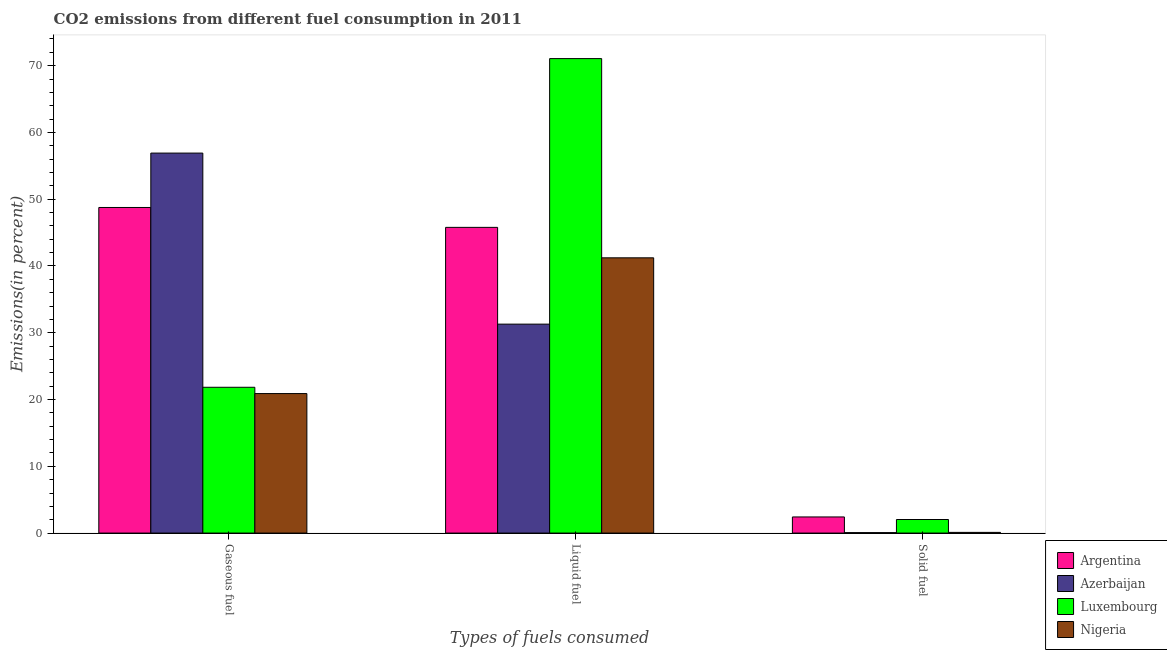How many different coloured bars are there?
Provide a short and direct response. 4. How many groups of bars are there?
Offer a very short reply. 3. How many bars are there on the 1st tick from the left?
Provide a succinct answer. 4. How many bars are there on the 3rd tick from the right?
Provide a short and direct response. 4. What is the label of the 1st group of bars from the left?
Provide a succinct answer. Gaseous fuel. What is the percentage of solid fuel emission in Nigeria?
Your answer should be compact. 0.1. Across all countries, what is the maximum percentage of gaseous fuel emission?
Your response must be concise. 56.9. Across all countries, what is the minimum percentage of liquid fuel emission?
Provide a succinct answer. 31.29. In which country was the percentage of liquid fuel emission maximum?
Your response must be concise. Luxembourg. In which country was the percentage of liquid fuel emission minimum?
Your answer should be compact. Azerbaijan. What is the total percentage of liquid fuel emission in the graph?
Your answer should be compact. 189.35. What is the difference between the percentage of gaseous fuel emission in Argentina and that in Azerbaijan?
Give a very brief answer. -8.14. What is the difference between the percentage of solid fuel emission in Luxembourg and the percentage of liquid fuel emission in Azerbaijan?
Make the answer very short. -29.26. What is the average percentage of liquid fuel emission per country?
Provide a succinct answer. 47.34. What is the difference between the percentage of gaseous fuel emission and percentage of liquid fuel emission in Azerbaijan?
Ensure brevity in your answer.  25.61. What is the ratio of the percentage of solid fuel emission in Luxembourg to that in Azerbaijan?
Provide a succinct answer. 30.89. Is the percentage of solid fuel emission in Nigeria less than that in Argentina?
Your answer should be very brief. Yes. Is the difference between the percentage of liquid fuel emission in Luxembourg and Argentina greater than the difference between the percentage of solid fuel emission in Luxembourg and Argentina?
Your response must be concise. Yes. What is the difference between the highest and the second highest percentage of liquid fuel emission?
Provide a succinct answer. 25.28. What is the difference between the highest and the lowest percentage of gaseous fuel emission?
Make the answer very short. 36.01. Is the sum of the percentage of liquid fuel emission in Luxembourg and Azerbaijan greater than the maximum percentage of gaseous fuel emission across all countries?
Keep it short and to the point. Yes. What does the 3rd bar from the left in Gaseous fuel represents?
Make the answer very short. Luxembourg. What does the 3rd bar from the right in Liquid fuel represents?
Offer a very short reply. Azerbaijan. How many bars are there?
Provide a succinct answer. 12. Are the values on the major ticks of Y-axis written in scientific E-notation?
Offer a very short reply. No. Does the graph contain any zero values?
Provide a short and direct response. No. Does the graph contain grids?
Give a very brief answer. No. Where does the legend appear in the graph?
Your answer should be compact. Bottom right. How many legend labels are there?
Offer a terse response. 4. How are the legend labels stacked?
Offer a terse response. Vertical. What is the title of the graph?
Provide a short and direct response. CO2 emissions from different fuel consumption in 2011. What is the label or title of the X-axis?
Your response must be concise. Types of fuels consumed. What is the label or title of the Y-axis?
Your answer should be compact. Emissions(in percent). What is the Emissions(in percent) of Argentina in Gaseous fuel?
Provide a short and direct response. 48.76. What is the Emissions(in percent) in Azerbaijan in Gaseous fuel?
Ensure brevity in your answer.  56.9. What is the Emissions(in percent) of Luxembourg in Gaseous fuel?
Offer a very short reply. 21.83. What is the Emissions(in percent) in Nigeria in Gaseous fuel?
Offer a very short reply. 20.89. What is the Emissions(in percent) in Argentina in Liquid fuel?
Your answer should be very brief. 45.78. What is the Emissions(in percent) of Azerbaijan in Liquid fuel?
Your answer should be very brief. 31.29. What is the Emissions(in percent) in Luxembourg in Liquid fuel?
Your answer should be very brief. 71.06. What is the Emissions(in percent) in Nigeria in Liquid fuel?
Your response must be concise. 41.22. What is the Emissions(in percent) of Argentina in Solid fuel?
Provide a short and direct response. 2.42. What is the Emissions(in percent) in Azerbaijan in Solid fuel?
Keep it short and to the point. 0.07. What is the Emissions(in percent) of Luxembourg in Solid fuel?
Your response must be concise. 2.03. What is the Emissions(in percent) of Nigeria in Solid fuel?
Your answer should be very brief. 0.1. Across all Types of fuels consumed, what is the maximum Emissions(in percent) of Argentina?
Keep it short and to the point. 48.76. Across all Types of fuels consumed, what is the maximum Emissions(in percent) of Azerbaijan?
Your answer should be compact. 56.9. Across all Types of fuels consumed, what is the maximum Emissions(in percent) in Luxembourg?
Offer a terse response. 71.06. Across all Types of fuels consumed, what is the maximum Emissions(in percent) of Nigeria?
Provide a short and direct response. 41.22. Across all Types of fuels consumed, what is the minimum Emissions(in percent) in Argentina?
Provide a short and direct response. 2.42. Across all Types of fuels consumed, what is the minimum Emissions(in percent) of Azerbaijan?
Provide a succinct answer. 0.07. Across all Types of fuels consumed, what is the minimum Emissions(in percent) in Luxembourg?
Provide a succinct answer. 2.03. Across all Types of fuels consumed, what is the minimum Emissions(in percent) in Nigeria?
Make the answer very short. 0.1. What is the total Emissions(in percent) of Argentina in the graph?
Provide a short and direct response. 96.96. What is the total Emissions(in percent) in Azerbaijan in the graph?
Offer a terse response. 88.26. What is the total Emissions(in percent) in Luxembourg in the graph?
Keep it short and to the point. 94.92. What is the total Emissions(in percent) in Nigeria in the graph?
Keep it short and to the point. 62.22. What is the difference between the Emissions(in percent) of Argentina in Gaseous fuel and that in Liquid fuel?
Ensure brevity in your answer.  2.98. What is the difference between the Emissions(in percent) in Azerbaijan in Gaseous fuel and that in Liquid fuel?
Provide a succinct answer. 25.61. What is the difference between the Emissions(in percent) in Luxembourg in Gaseous fuel and that in Liquid fuel?
Make the answer very short. -49.22. What is the difference between the Emissions(in percent) in Nigeria in Gaseous fuel and that in Liquid fuel?
Your response must be concise. -20.33. What is the difference between the Emissions(in percent) in Argentina in Gaseous fuel and that in Solid fuel?
Your answer should be compact. 46.34. What is the difference between the Emissions(in percent) in Azerbaijan in Gaseous fuel and that in Solid fuel?
Provide a short and direct response. 56.84. What is the difference between the Emissions(in percent) in Luxembourg in Gaseous fuel and that in Solid fuel?
Offer a terse response. 19.8. What is the difference between the Emissions(in percent) in Nigeria in Gaseous fuel and that in Solid fuel?
Keep it short and to the point. 20.79. What is the difference between the Emissions(in percent) of Argentina in Liquid fuel and that in Solid fuel?
Provide a short and direct response. 43.36. What is the difference between the Emissions(in percent) of Azerbaijan in Liquid fuel and that in Solid fuel?
Your answer should be very brief. 31.23. What is the difference between the Emissions(in percent) in Luxembourg in Liquid fuel and that in Solid fuel?
Give a very brief answer. 69.03. What is the difference between the Emissions(in percent) of Nigeria in Liquid fuel and that in Solid fuel?
Provide a short and direct response. 41.12. What is the difference between the Emissions(in percent) of Argentina in Gaseous fuel and the Emissions(in percent) of Azerbaijan in Liquid fuel?
Provide a short and direct response. 17.47. What is the difference between the Emissions(in percent) in Argentina in Gaseous fuel and the Emissions(in percent) in Luxembourg in Liquid fuel?
Your answer should be compact. -22.3. What is the difference between the Emissions(in percent) of Argentina in Gaseous fuel and the Emissions(in percent) of Nigeria in Liquid fuel?
Offer a very short reply. 7.54. What is the difference between the Emissions(in percent) of Azerbaijan in Gaseous fuel and the Emissions(in percent) of Luxembourg in Liquid fuel?
Provide a succinct answer. -14.15. What is the difference between the Emissions(in percent) in Azerbaijan in Gaseous fuel and the Emissions(in percent) in Nigeria in Liquid fuel?
Make the answer very short. 15.68. What is the difference between the Emissions(in percent) of Luxembourg in Gaseous fuel and the Emissions(in percent) of Nigeria in Liquid fuel?
Give a very brief answer. -19.39. What is the difference between the Emissions(in percent) of Argentina in Gaseous fuel and the Emissions(in percent) of Azerbaijan in Solid fuel?
Your answer should be compact. 48.69. What is the difference between the Emissions(in percent) of Argentina in Gaseous fuel and the Emissions(in percent) of Luxembourg in Solid fuel?
Your response must be concise. 46.73. What is the difference between the Emissions(in percent) in Argentina in Gaseous fuel and the Emissions(in percent) in Nigeria in Solid fuel?
Offer a terse response. 48.66. What is the difference between the Emissions(in percent) of Azerbaijan in Gaseous fuel and the Emissions(in percent) of Luxembourg in Solid fuel?
Your answer should be very brief. 54.87. What is the difference between the Emissions(in percent) in Azerbaijan in Gaseous fuel and the Emissions(in percent) in Nigeria in Solid fuel?
Offer a very short reply. 56.8. What is the difference between the Emissions(in percent) in Luxembourg in Gaseous fuel and the Emissions(in percent) in Nigeria in Solid fuel?
Provide a succinct answer. 21.73. What is the difference between the Emissions(in percent) of Argentina in Liquid fuel and the Emissions(in percent) of Azerbaijan in Solid fuel?
Provide a short and direct response. 45.72. What is the difference between the Emissions(in percent) in Argentina in Liquid fuel and the Emissions(in percent) in Luxembourg in Solid fuel?
Offer a very short reply. 43.75. What is the difference between the Emissions(in percent) of Argentina in Liquid fuel and the Emissions(in percent) of Nigeria in Solid fuel?
Keep it short and to the point. 45.68. What is the difference between the Emissions(in percent) of Azerbaijan in Liquid fuel and the Emissions(in percent) of Luxembourg in Solid fuel?
Provide a succinct answer. 29.26. What is the difference between the Emissions(in percent) in Azerbaijan in Liquid fuel and the Emissions(in percent) in Nigeria in Solid fuel?
Provide a short and direct response. 31.19. What is the difference between the Emissions(in percent) of Luxembourg in Liquid fuel and the Emissions(in percent) of Nigeria in Solid fuel?
Keep it short and to the point. 70.95. What is the average Emissions(in percent) in Argentina per Types of fuels consumed?
Keep it short and to the point. 32.32. What is the average Emissions(in percent) in Azerbaijan per Types of fuels consumed?
Provide a short and direct response. 29.42. What is the average Emissions(in percent) of Luxembourg per Types of fuels consumed?
Keep it short and to the point. 31.64. What is the average Emissions(in percent) in Nigeria per Types of fuels consumed?
Offer a very short reply. 20.74. What is the difference between the Emissions(in percent) of Argentina and Emissions(in percent) of Azerbaijan in Gaseous fuel?
Offer a terse response. -8.14. What is the difference between the Emissions(in percent) of Argentina and Emissions(in percent) of Luxembourg in Gaseous fuel?
Offer a very short reply. 26.93. What is the difference between the Emissions(in percent) in Argentina and Emissions(in percent) in Nigeria in Gaseous fuel?
Ensure brevity in your answer.  27.87. What is the difference between the Emissions(in percent) in Azerbaijan and Emissions(in percent) in Luxembourg in Gaseous fuel?
Your answer should be compact. 35.07. What is the difference between the Emissions(in percent) in Azerbaijan and Emissions(in percent) in Nigeria in Gaseous fuel?
Your answer should be very brief. 36.01. What is the difference between the Emissions(in percent) in Luxembourg and Emissions(in percent) in Nigeria in Gaseous fuel?
Give a very brief answer. 0.94. What is the difference between the Emissions(in percent) of Argentina and Emissions(in percent) of Azerbaijan in Liquid fuel?
Make the answer very short. 14.49. What is the difference between the Emissions(in percent) of Argentina and Emissions(in percent) of Luxembourg in Liquid fuel?
Make the answer very short. -25.28. What is the difference between the Emissions(in percent) in Argentina and Emissions(in percent) in Nigeria in Liquid fuel?
Provide a short and direct response. 4.56. What is the difference between the Emissions(in percent) in Azerbaijan and Emissions(in percent) in Luxembourg in Liquid fuel?
Ensure brevity in your answer.  -39.77. What is the difference between the Emissions(in percent) of Azerbaijan and Emissions(in percent) of Nigeria in Liquid fuel?
Provide a succinct answer. -9.93. What is the difference between the Emissions(in percent) in Luxembourg and Emissions(in percent) in Nigeria in Liquid fuel?
Your answer should be compact. 29.84. What is the difference between the Emissions(in percent) in Argentina and Emissions(in percent) in Azerbaijan in Solid fuel?
Offer a very short reply. 2.35. What is the difference between the Emissions(in percent) of Argentina and Emissions(in percent) of Luxembourg in Solid fuel?
Your answer should be compact. 0.38. What is the difference between the Emissions(in percent) of Argentina and Emissions(in percent) of Nigeria in Solid fuel?
Offer a terse response. 2.31. What is the difference between the Emissions(in percent) in Azerbaijan and Emissions(in percent) in Luxembourg in Solid fuel?
Ensure brevity in your answer.  -1.97. What is the difference between the Emissions(in percent) in Azerbaijan and Emissions(in percent) in Nigeria in Solid fuel?
Ensure brevity in your answer.  -0.04. What is the difference between the Emissions(in percent) in Luxembourg and Emissions(in percent) in Nigeria in Solid fuel?
Offer a very short reply. 1.93. What is the ratio of the Emissions(in percent) of Argentina in Gaseous fuel to that in Liquid fuel?
Your answer should be compact. 1.07. What is the ratio of the Emissions(in percent) in Azerbaijan in Gaseous fuel to that in Liquid fuel?
Offer a very short reply. 1.82. What is the ratio of the Emissions(in percent) in Luxembourg in Gaseous fuel to that in Liquid fuel?
Keep it short and to the point. 0.31. What is the ratio of the Emissions(in percent) in Nigeria in Gaseous fuel to that in Liquid fuel?
Your answer should be very brief. 0.51. What is the ratio of the Emissions(in percent) in Argentina in Gaseous fuel to that in Solid fuel?
Your answer should be compact. 20.18. What is the ratio of the Emissions(in percent) of Azerbaijan in Gaseous fuel to that in Solid fuel?
Ensure brevity in your answer.  865.33. What is the ratio of the Emissions(in percent) in Luxembourg in Gaseous fuel to that in Solid fuel?
Your response must be concise. 10.75. What is the ratio of the Emissions(in percent) of Nigeria in Gaseous fuel to that in Solid fuel?
Offer a very short reply. 200.6. What is the ratio of the Emissions(in percent) in Argentina in Liquid fuel to that in Solid fuel?
Your answer should be very brief. 18.95. What is the ratio of the Emissions(in percent) in Azerbaijan in Liquid fuel to that in Solid fuel?
Make the answer very short. 475.83. What is the ratio of the Emissions(in percent) of Luxembourg in Liquid fuel to that in Solid fuel?
Ensure brevity in your answer.  34.98. What is the ratio of the Emissions(in percent) in Nigeria in Liquid fuel to that in Solid fuel?
Give a very brief answer. 395.8. What is the difference between the highest and the second highest Emissions(in percent) in Argentina?
Keep it short and to the point. 2.98. What is the difference between the highest and the second highest Emissions(in percent) in Azerbaijan?
Keep it short and to the point. 25.61. What is the difference between the highest and the second highest Emissions(in percent) in Luxembourg?
Make the answer very short. 49.22. What is the difference between the highest and the second highest Emissions(in percent) of Nigeria?
Offer a very short reply. 20.33. What is the difference between the highest and the lowest Emissions(in percent) in Argentina?
Provide a short and direct response. 46.34. What is the difference between the highest and the lowest Emissions(in percent) of Azerbaijan?
Keep it short and to the point. 56.84. What is the difference between the highest and the lowest Emissions(in percent) in Luxembourg?
Ensure brevity in your answer.  69.03. What is the difference between the highest and the lowest Emissions(in percent) in Nigeria?
Offer a very short reply. 41.12. 